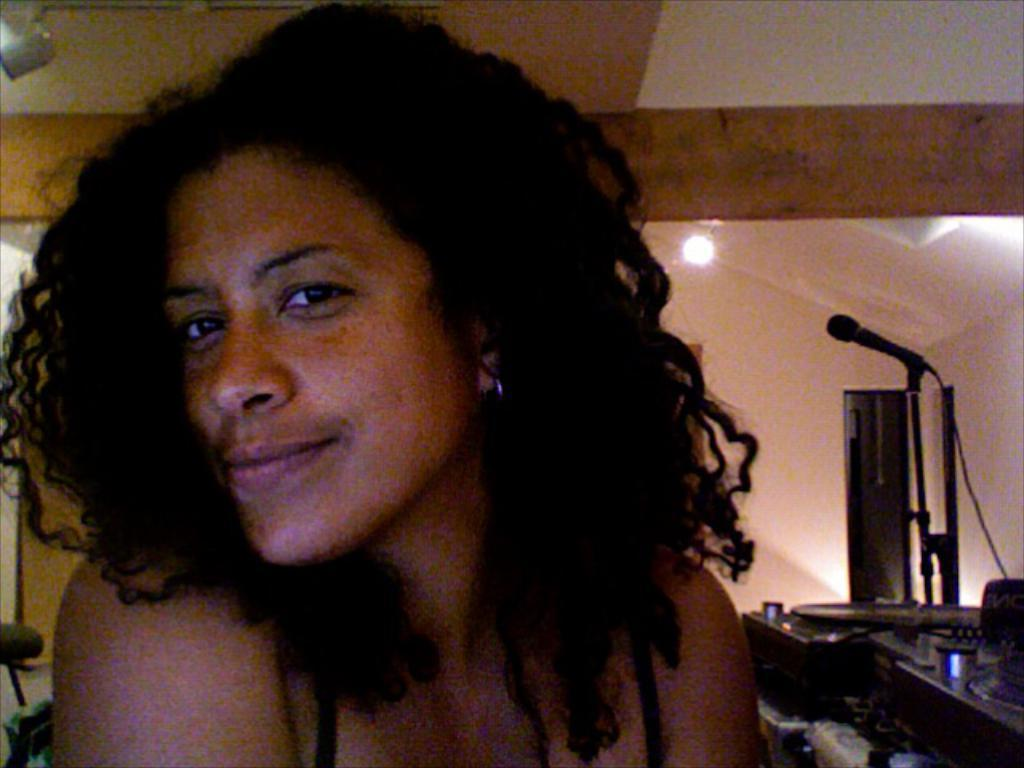Who is present in the image? There is a woman in the image. What object is on the right side of the image? There is a microphone on the right side of the image. What else can be seen on the right side of the image? There are objects on the right side of the image. What parts of the room are visible in the image? The walls, roof, and lights are visible in the image. How many crows are perched on the woman's shoulder in the image? There are no crows present in the image. What is the size of the wing visible in the image? There is no wing visible in the image. 